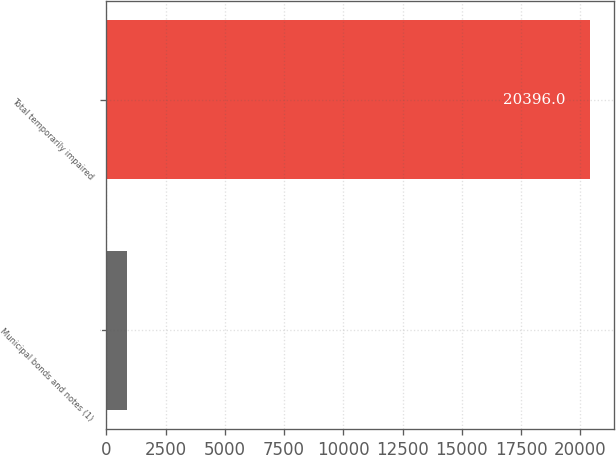<chart> <loc_0><loc_0><loc_500><loc_500><bar_chart><fcel>Municipal bonds and notes (1)<fcel>Total temporarily impaired<nl><fcel>893<fcel>20396<nl></chart> 